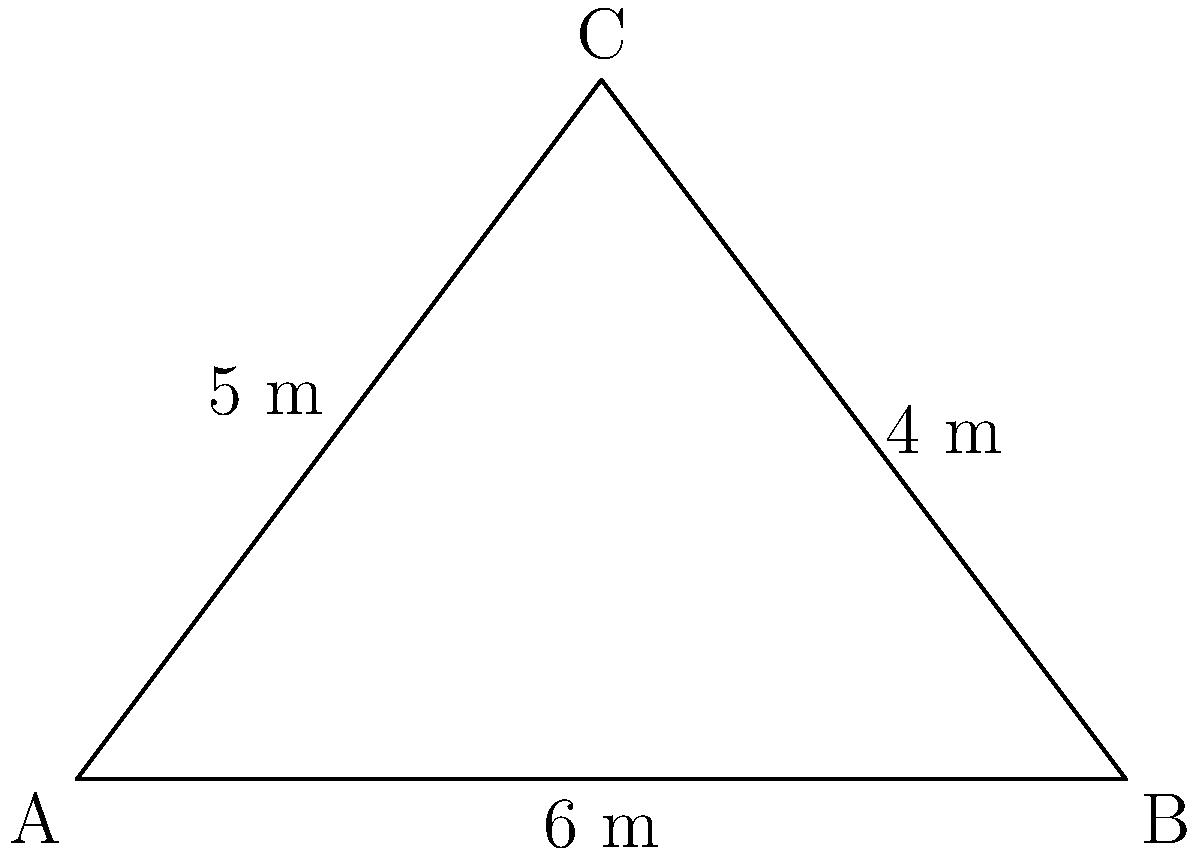A local artist has been commissioned to paint a mural on a triangular wall in the community center. The wall has the following dimensions: base of 6 meters, height of 4 meters, and a hypotenuse of 5 meters. What is the area of the wall that needs to be painted? To find the area of the triangular wall, we can use the formula for the area of a triangle:

$$A = \frac{1}{2} \times base \times height$$

Given:
- Base = 6 meters
- Height = 4 meters

Step 1: Substitute the values into the formula
$$A = \frac{1}{2} \times 6 \times 4$$

Step 2: Multiply
$$A = \frac{1}{2} \times 24$$

Step 3: Calculate the final result
$$A = 12$$

Therefore, the area of the triangular wall is 12 square meters.

Note: The hypotenuse length (5 meters) is not needed for this calculation but can be used to verify the triangle's right-angledness using the Pythagorean theorem if required.
Answer: 12 m² 